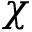Convert formula to latex. <formula><loc_0><loc_0><loc_500><loc_500>\chi</formula> 